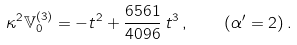Convert formula to latex. <formula><loc_0><loc_0><loc_500><loc_500>\kappa ^ { 2 } \mathbb { V } ^ { ( 3 ) } _ { 0 } = - t ^ { 2 } + \frac { 6 5 6 1 } { 4 0 9 6 } \, t ^ { 3 } \, , \quad ( \alpha ^ { \prime } = 2 ) \, .</formula> 